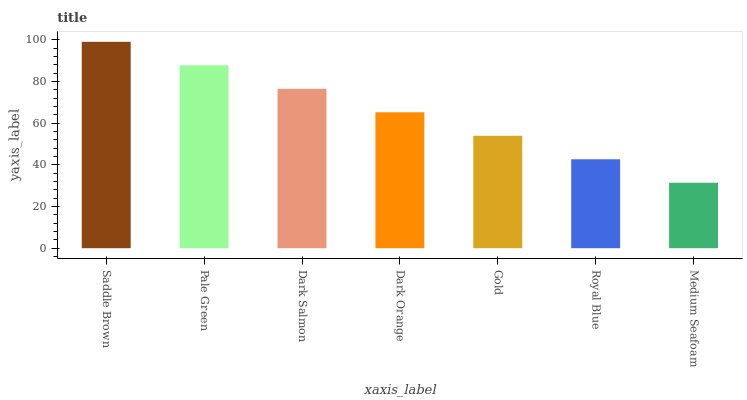Is Medium Seafoam the minimum?
Answer yes or no. Yes. Is Saddle Brown the maximum?
Answer yes or no. Yes. Is Pale Green the minimum?
Answer yes or no. No. Is Pale Green the maximum?
Answer yes or no. No. Is Saddle Brown greater than Pale Green?
Answer yes or no. Yes. Is Pale Green less than Saddle Brown?
Answer yes or no. Yes. Is Pale Green greater than Saddle Brown?
Answer yes or no. No. Is Saddle Brown less than Pale Green?
Answer yes or no. No. Is Dark Orange the high median?
Answer yes or no. Yes. Is Dark Orange the low median?
Answer yes or no. Yes. Is Medium Seafoam the high median?
Answer yes or no. No. Is Royal Blue the low median?
Answer yes or no. No. 